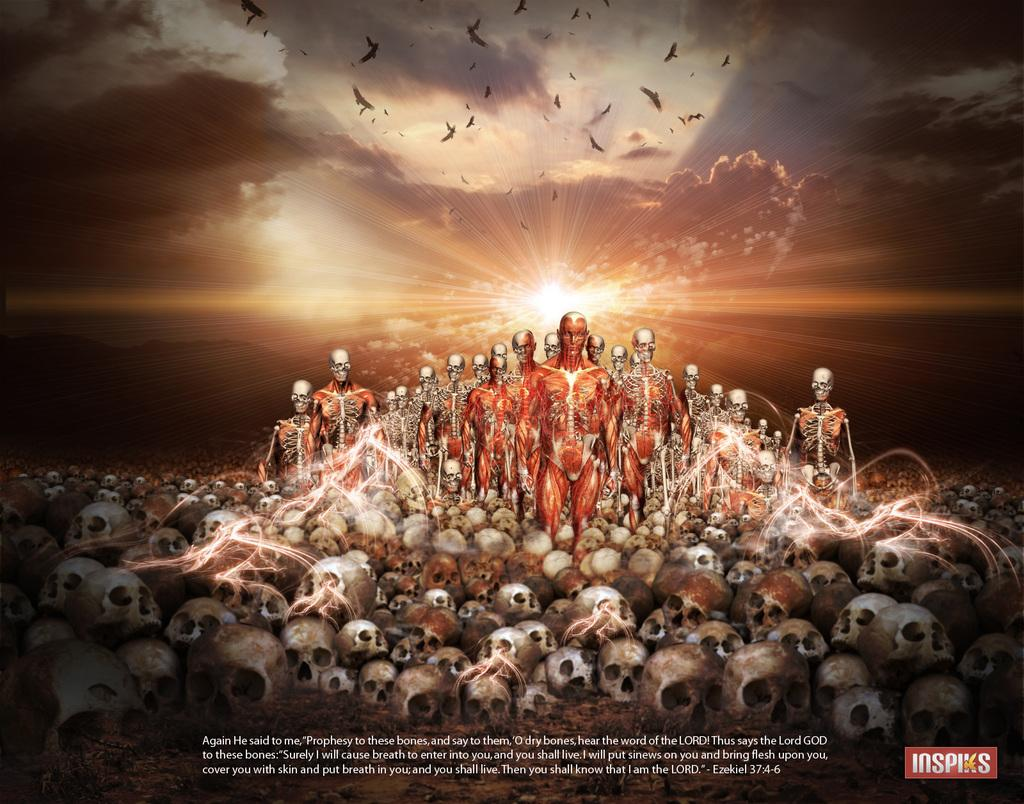<image>
Render a clear and concise summary of the photo. An Inspiks ad features skulls, bones, and walking skeletons. 